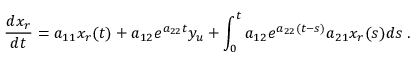<formula> <loc_0><loc_0><loc_500><loc_500>\frac { d x _ { r } } { d t } = a _ { 1 1 } x _ { r } ( t ) + a _ { 1 2 } e ^ { a _ { 2 2 } t } y _ { u } + \int _ { 0 } ^ { t } a _ { 1 2 } e ^ { a _ { 2 2 } ( t - s ) } a _ { 2 1 } x _ { r } ( s ) d s \, .</formula> 